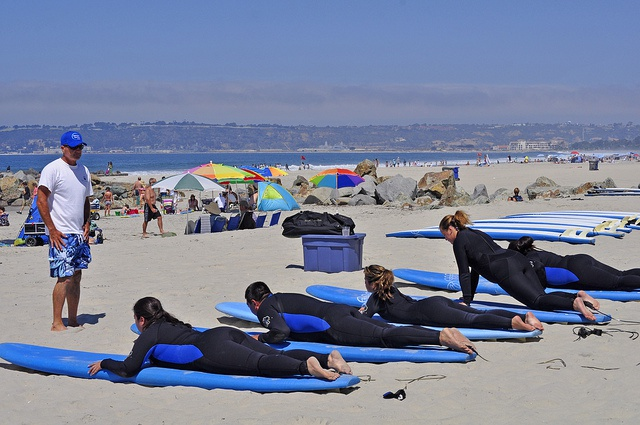Describe the objects in this image and their specific colors. I can see people in gray, black, navy, blue, and darkblue tones, people in gray, black, navy, and blue tones, people in gray, lavender, darkgray, black, and maroon tones, surfboard in gray, blue, and lightblue tones, and people in gray, black, brown, and lightpink tones in this image. 